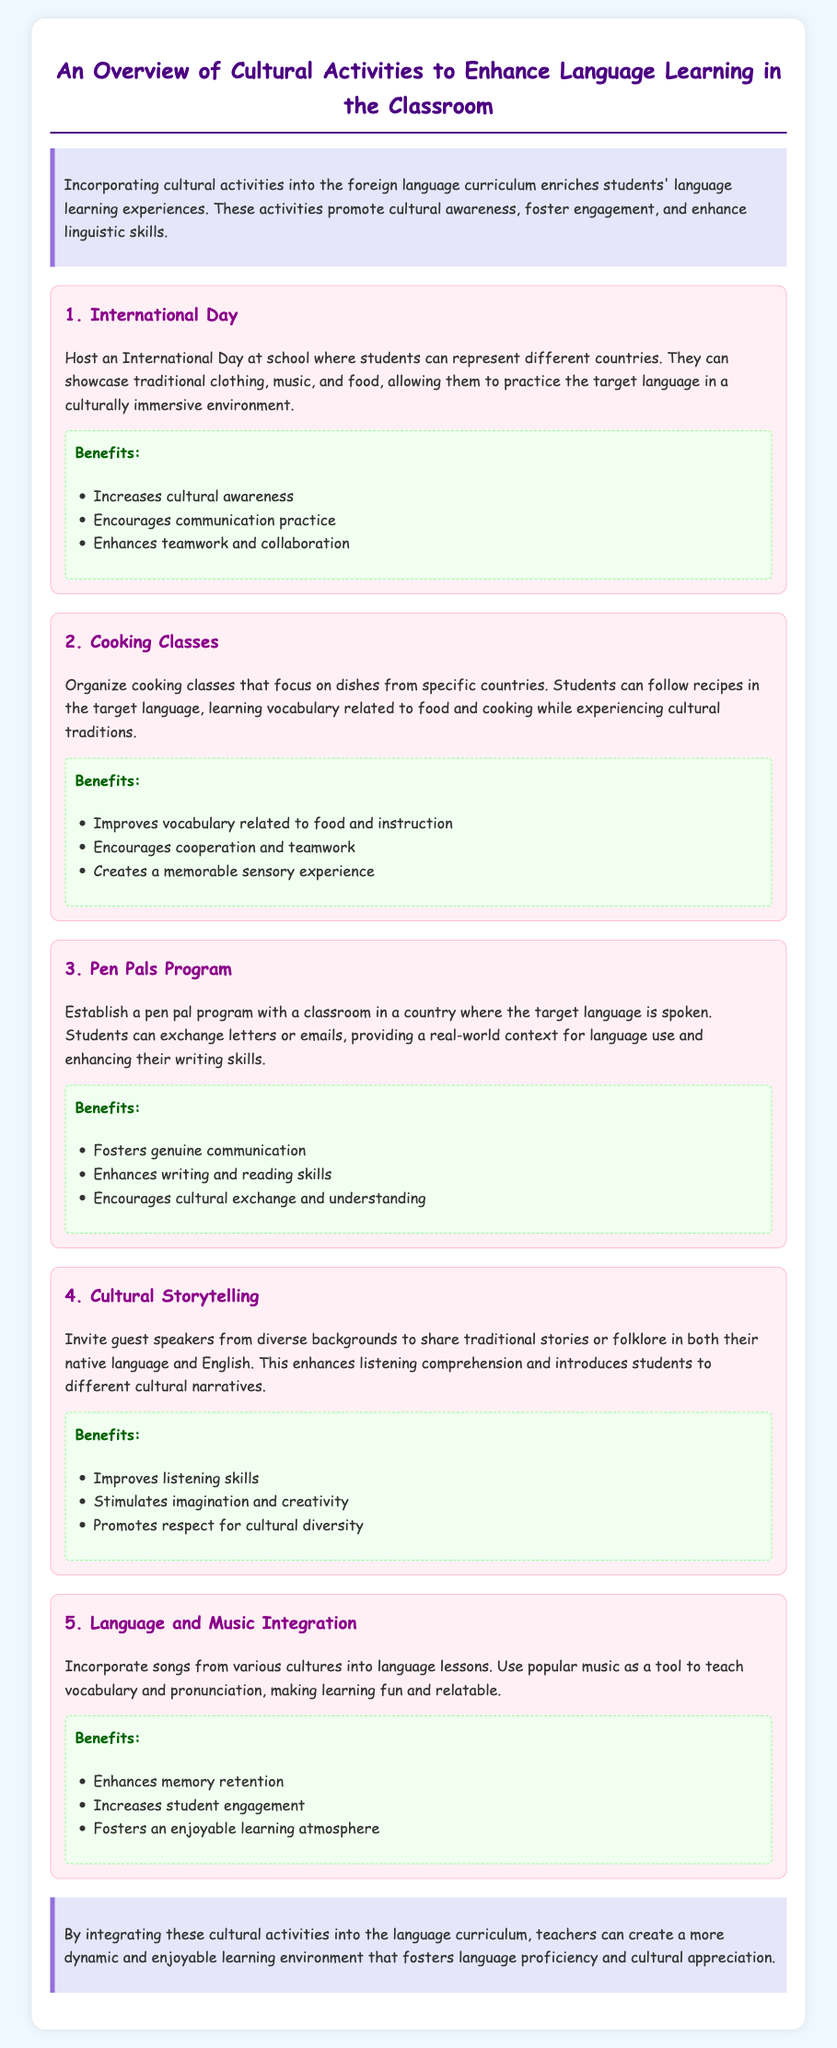What is the title of the document? The title is found at the top of the document in the main heading.
Answer: An Overview of Cultural Activities to Enhance Language Learning in the Classroom How many activities are listed in the document? The number of activities is indicated by the headings in the activities section of the document.
Answer: 5 What is the first activity mentioned? The first activity is noted at the beginning of the activities section.
Answer: International Day What benefit is associated with cooking classes? Benefits are listed under each activity, highlighting specific advantages.
Answer: Improves vocabulary related to food and instruction What does the pen pals program enhance? The enhancement is noted under the benefits section for that activity.
Answer: Writing and reading skills What type of storytelling is encouraged in the document? The type of storytelling is specified in the section describing cultural storytelling.
Answer: Cultural storytelling Which integration is suggested in the language lessons? The integration is specified in the last activity section.
Answer: Language and Music Integration What key aspect does the conclusion emphasize? The emphasis is given in the final paragraph summarizing the document's purpose.
Answer: Dynamic and enjoyable learning environment 